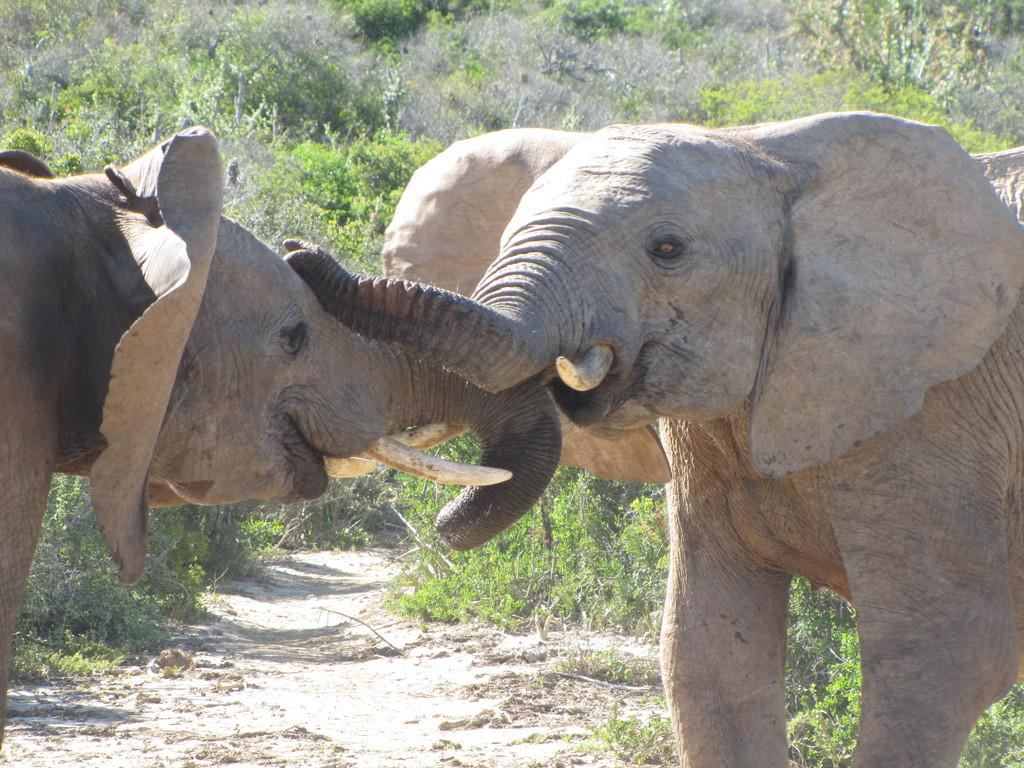How many elephants are in the image? There are two elephants in the image. What are the elephants doing in the image? The elephants are fighting in the image. What can be seen in the background of the image? There are trees, plants, grass, and a few other objects in the background of the image. Are there any dinosaurs in the image? No, there are no dinosaurs present in the image. 